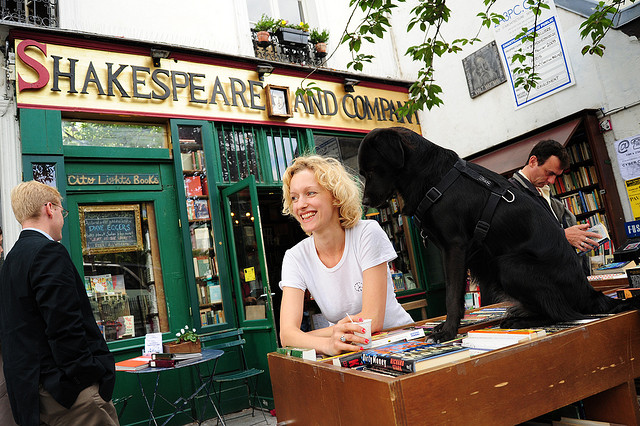Please identify all text content in this image. SHAKESPEARE AND COMPANY Cito Lights Books ECCERS 